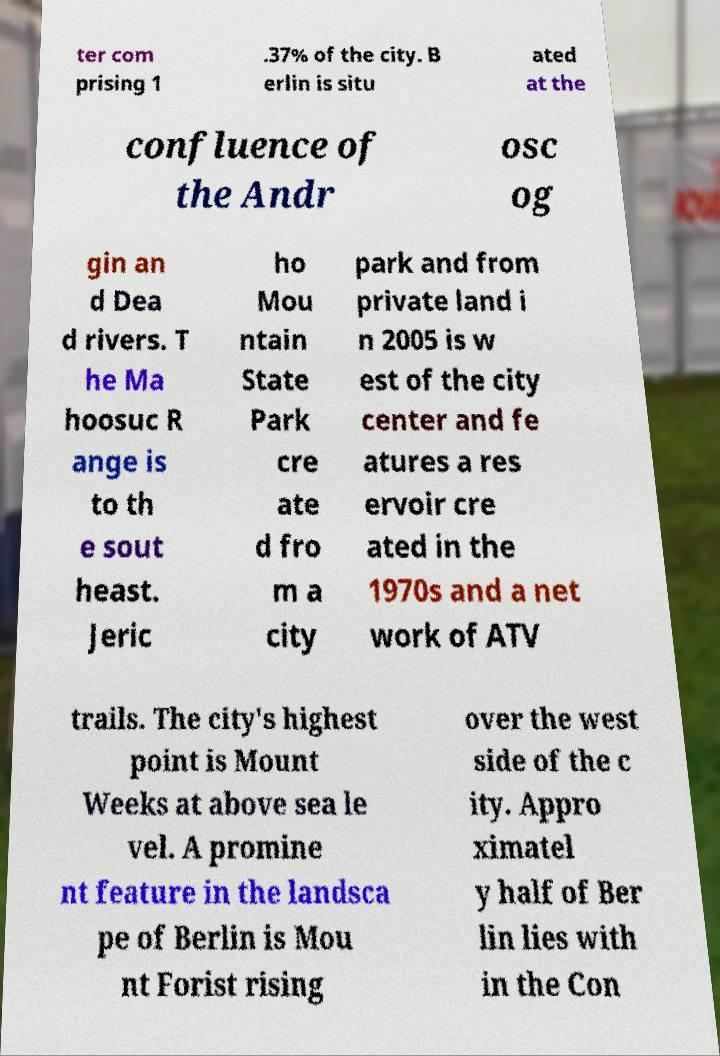Can you accurately transcribe the text from the provided image for me? ter com prising 1 .37% of the city. B erlin is situ ated at the confluence of the Andr osc og gin an d Dea d rivers. T he Ma hoosuc R ange is to th e sout heast. Jeric ho Mou ntain State Park cre ate d fro m a city park and from private land i n 2005 is w est of the city center and fe atures a res ervoir cre ated in the 1970s and a net work of ATV trails. The city's highest point is Mount Weeks at above sea le vel. A promine nt feature in the landsca pe of Berlin is Mou nt Forist rising over the west side of the c ity. Appro ximatel y half of Ber lin lies with in the Con 